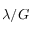<formula> <loc_0><loc_0><loc_500><loc_500>\lambda / G</formula> 